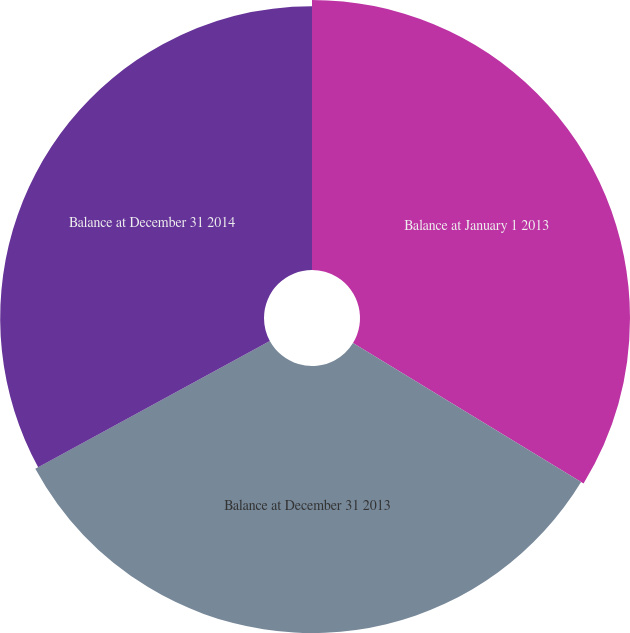Convert chart to OTSL. <chart><loc_0><loc_0><loc_500><loc_500><pie_chart><fcel>Balance at January 1 2013<fcel>Balance at December 31 2013<fcel>Balance at December 31 2014<nl><fcel>33.71%<fcel>33.35%<fcel>32.94%<nl></chart> 